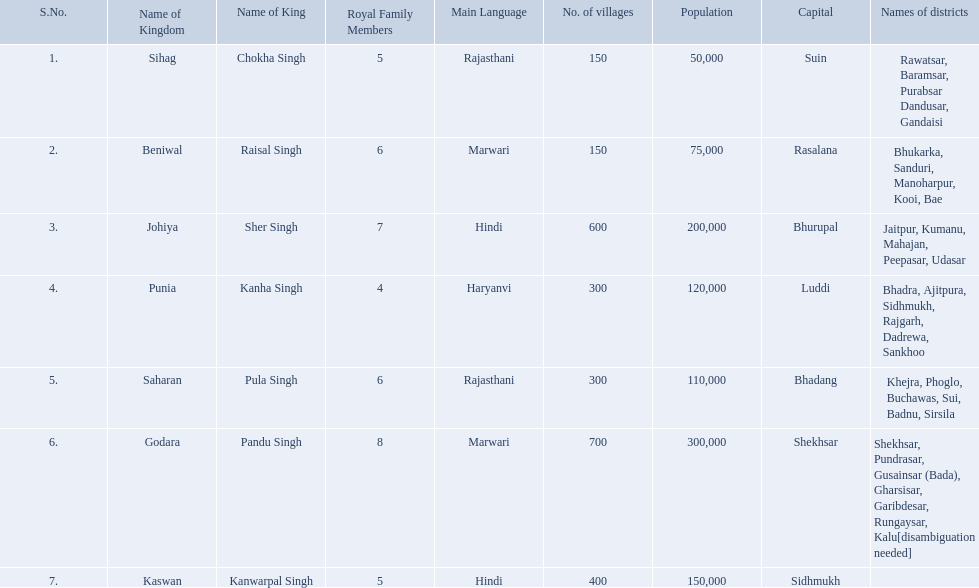What is the most amount of villages in a kingdom? 700. What is the second most amount of villages in a kingdom? 600. What kingdom has 600 villages? Johiya. What are all of the kingdoms? Sihag, Beniwal, Johiya, Punia, Saharan, Godara, Kaswan. How many villages do they contain? 150, 150, 600, 300, 300, 700, 400. How many are in godara? 700. Which kingdom comes next in highest amount of villages? Johiya. 